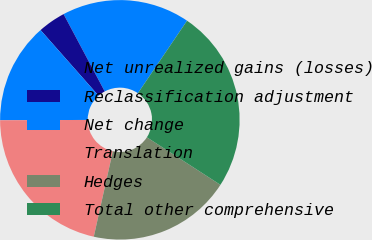Convert chart. <chart><loc_0><loc_0><loc_500><loc_500><pie_chart><fcel>Net unrealized gains (losses)<fcel>Reclassification adjustment<fcel>Net change<fcel>Translation<fcel>Hedges<fcel>Total other comprehensive<nl><fcel>17.27%<fcel>3.73%<fcel>13.54%<fcel>21.45%<fcel>19.36%<fcel>24.65%<nl></chart> 